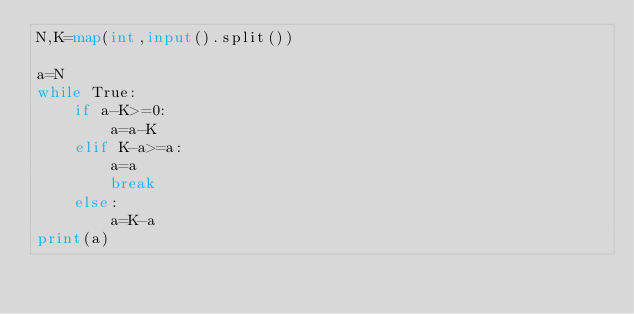<code> <loc_0><loc_0><loc_500><loc_500><_Python_>N,K=map(int,input().split())

a=N
while True:
    if a-K>=0:
        a=a-K
    elif K-a>=a:
        a=a
        break
    else:
        a=K-a
print(a)</code> 